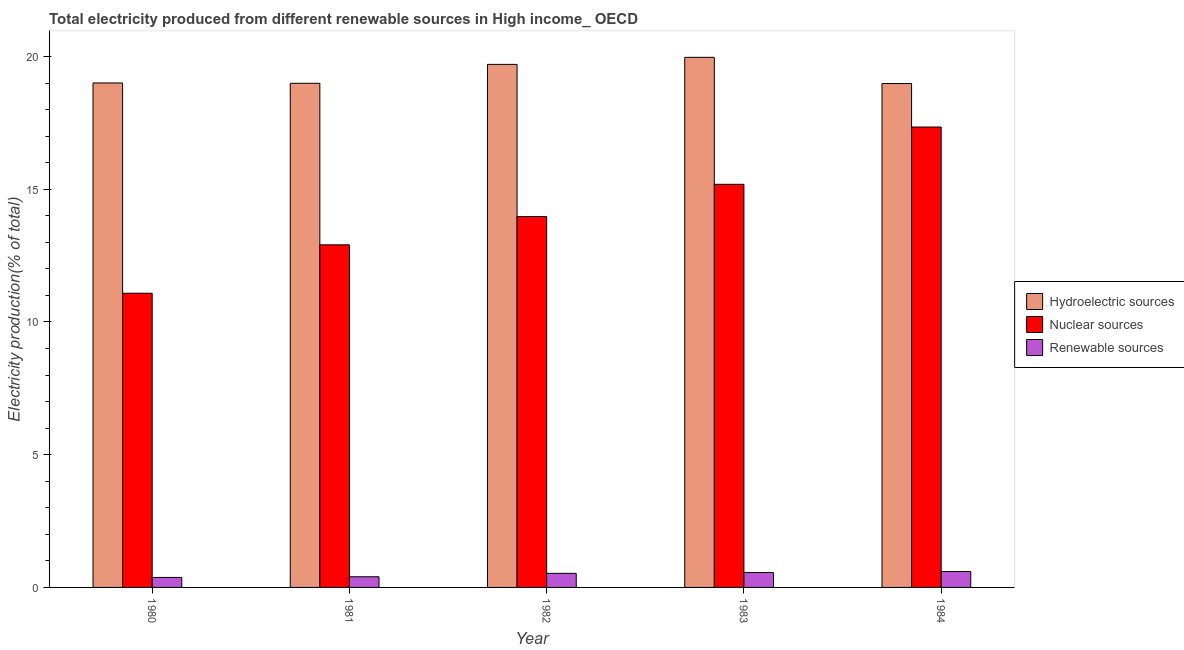How many different coloured bars are there?
Provide a short and direct response. 3. Are the number of bars on each tick of the X-axis equal?
Offer a terse response. Yes. What is the label of the 3rd group of bars from the left?
Ensure brevity in your answer.  1982. In how many cases, is the number of bars for a given year not equal to the number of legend labels?
Give a very brief answer. 0. What is the percentage of electricity produced by nuclear sources in 1983?
Offer a very short reply. 15.19. Across all years, what is the maximum percentage of electricity produced by hydroelectric sources?
Keep it short and to the point. 19.97. Across all years, what is the minimum percentage of electricity produced by hydroelectric sources?
Offer a very short reply. 18.98. In which year was the percentage of electricity produced by hydroelectric sources minimum?
Give a very brief answer. 1984. What is the total percentage of electricity produced by nuclear sources in the graph?
Offer a very short reply. 70.49. What is the difference between the percentage of electricity produced by hydroelectric sources in 1983 and that in 1984?
Offer a terse response. 0.99. What is the difference between the percentage of electricity produced by renewable sources in 1981 and the percentage of electricity produced by hydroelectric sources in 1984?
Provide a short and direct response. -0.2. What is the average percentage of electricity produced by nuclear sources per year?
Make the answer very short. 14.1. In how many years, is the percentage of electricity produced by renewable sources greater than 18 %?
Your response must be concise. 0. What is the ratio of the percentage of electricity produced by nuclear sources in 1980 to that in 1982?
Your answer should be compact. 0.79. Is the percentage of electricity produced by renewable sources in 1980 less than that in 1984?
Provide a succinct answer. Yes. What is the difference between the highest and the second highest percentage of electricity produced by renewable sources?
Ensure brevity in your answer.  0.04. What is the difference between the highest and the lowest percentage of electricity produced by nuclear sources?
Provide a succinct answer. 6.26. In how many years, is the percentage of electricity produced by renewable sources greater than the average percentage of electricity produced by renewable sources taken over all years?
Ensure brevity in your answer.  3. Is the sum of the percentage of electricity produced by nuclear sources in 1980 and 1982 greater than the maximum percentage of electricity produced by hydroelectric sources across all years?
Your answer should be compact. Yes. What does the 2nd bar from the left in 1980 represents?
Your answer should be very brief. Nuclear sources. What does the 1st bar from the right in 1980 represents?
Your answer should be compact. Renewable sources. How many bars are there?
Provide a short and direct response. 15. How many years are there in the graph?
Provide a short and direct response. 5. What is the difference between two consecutive major ticks on the Y-axis?
Ensure brevity in your answer.  5. Are the values on the major ticks of Y-axis written in scientific E-notation?
Provide a short and direct response. No. Where does the legend appear in the graph?
Offer a very short reply. Center right. How many legend labels are there?
Offer a terse response. 3. How are the legend labels stacked?
Your response must be concise. Vertical. What is the title of the graph?
Offer a terse response. Total electricity produced from different renewable sources in High income_ OECD. Does "Primary education" appear as one of the legend labels in the graph?
Your answer should be very brief. No. What is the label or title of the X-axis?
Your response must be concise. Year. What is the Electricity production(% of total) of Hydroelectric sources in 1980?
Your answer should be very brief. 19. What is the Electricity production(% of total) of Nuclear sources in 1980?
Provide a succinct answer. 11.08. What is the Electricity production(% of total) in Renewable sources in 1980?
Make the answer very short. 0.38. What is the Electricity production(% of total) of Hydroelectric sources in 1981?
Offer a terse response. 18.99. What is the Electricity production(% of total) of Nuclear sources in 1981?
Make the answer very short. 12.91. What is the Electricity production(% of total) of Renewable sources in 1981?
Provide a short and direct response. 0.4. What is the Electricity production(% of total) in Hydroelectric sources in 1982?
Your response must be concise. 19.7. What is the Electricity production(% of total) of Nuclear sources in 1982?
Keep it short and to the point. 13.97. What is the Electricity production(% of total) of Renewable sources in 1982?
Offer a very short reply. 0.53. What is the Electricity production(% of total) of Hydroelectric sources in 1983?
Your response must be concise. 19.97. What is the Electricity production(% of total) of Nuclear sources in 1983?
Offer a very short reply. 15.19. What is the Electricity production(% of total) of Renewable sources in 1983?
Your response must be concise. 0.56. What is the Electricity production(% of total) of Hydroelectric sources in 1984?
Provide a succinct answer. 18.98. What is the Electricity production(% of total) in Nuclear sources in 1984?
Provide a short and direct response. 17.34. What is the Electricity production(% of total) in Renewable sources in 1984?
Offer a terse response. 0.6. Across all years, what is the maximum Electricity production(% of total) of Hydroelectric sources?
Provide a succinct answer. 19.97. Across all years, what is the maximum Electricity production(% of total) in Nuclear sources?
Your response must be concise. 17.34. Across all years, what is the maximum Electricity production(% of total) in Renewable sources?
Your answer should be very brief. 0.6. Across all years, what is the minimum Electricity production(% of total) in Hydroelectric sources?
Keep it short and to the point. 18.98. Across all years, what is the minimum Electricity production(% of total) of Nuclear sources?
Your answer should be very brief. 11.08. Across all years, what is the minimum Electricity production(% of total) in Renewable sources?
Your answer should be compact. 0.38. What is the total Electricity production(% of total) in Hydroelectric sources in the graph?
Provide a short and direct response. 96.65. What is the total Electricity production(% of total) of Nuclear sources in the graph?
Your answer should be compact. 70.49. What is the total Electricity production(% of total) in Renewable sources in the graph?
Provide a short and direct response. 2.47. What is the difference between the Electricity production(% of total) in Hydroelectric sources in 1980 and that in 1981?
Your response must be concise. 0.01. What is the difference between the Electricity production(% of total) in Nuclear sources in 1980 and that in 1981?
Offer a terse response. -1.82. What is the difference between the Electricity production(% of total) in Renewable sources in 1980 and that in 1981?
Offer a very short reply. -0.03. What is the difference between the Electricity production(% of total) of Hydroelectric sources in 1980 and that in 1982?
Provide a succinct answer. -0.7. What is the difference between the Electricity production(% of total) in Nuclear sources in 1980 and that in 1982?
Ensure brevity in your answer.  -2.89. What is the difference between the Electricity production(% of total) of Renewable sources in 1980 and that in 1982?
Your answer should be very brief. -0.15. What is the difference between the Electricity production(% of total) in Hydroelectric sources in 1980 and that in 1983?
Your answer should be compact. -0.97. What is the difference between the Electricity production(% of total) of Nuclear sources in 1980 and that in 1983?
Provide a short and direct response. -4.1. What is the difference between the Electricity production(% of total) of Renewable sources in 1980 and that in 1983?
Offer a very short reply. -0.18. What is the difference between the Electricity production(% of total) of Hydroelectric sources in 1980 and that in 1984?
Offer a terse response. 0.02. What is the difference between the Electricity production(% of total) in Nuclear sources in 1980 and that in 1984?
Give a very brief answer. -6.26. What is the difference between the Electricity production(% of total) in Renewable sources in 1980 and that in 1984?
Your answer should be compact. -0.22. What is the difference between the Electricity production(% of total) of Hydroelectric sources in 1981 and that in 1982?
Make the answer very short. -0.71. What is the difference between the Electricity production(% of total) in Nuclear sources in 1981 and that in 1982?
Offer a very short reply. -1.07. What is the difference between the Electricity production(% of total) in Renewable sources in 1981 and that in 1982?
Provide a succinct answer. -0.13. What is the difference between the Electricity production(% of total) in Hydroelectric sources in 1981 and that in 1983?
Offer a very short reply. -0.98. What is the difference between the Electricity production(% of total) in Nuclear sources in 1981 and that in 1983?
Offer a very short reply. -2.28. What is the difference between the Electricity production(% of total) of Renewable sources in 1981 and that in 1983?
Your answer should be very brief. -0.16. What is the difference between the Electricity production(% of total) in Hydroelectric sources in 1981 and that in 1984?
Provide a succinct answer. 0.01. What is the difference between the Electricity production(% of total) in Nuclear sources in 1981 and that in 1984?
Provide a short and direct response. -4.44. What is the difference between the Electricity production(% of total) of Renewable sources in 1981 and that in 1984?
Offer a terse response. -0.2. What is the difference between the Electricity production(% of total) in Hydroelectric sources in 1982 and that in 1983?
Your answer should be very brief. -0.27. What is the difference between the Electricity production(% of total) in Nuclear sources in 1982 and that in 1983?
Your answer should be very brief. -1.21. What is the difference between the Electricity production(% of total) of Renewable sources in 1982 and that in 1983?
Ensure brevity in your answer.  -0.03. What is the difference between the Electricity production(% of total) of Hydroelectric sources in 1982 and that in 1984?
Your response must be concise. 0.72. What is the difference between the Electricity production(% of total) of Nuclear sources in 1982 and that in 1984?
Offer a terse response. -3.37. What is the difference between the Electricity production(% of total) in Renewable sources in 1982 and that in 1984?
Offer a very short reply. -0.07. What is the difference between the Electricity production(% of total) in Nuclear sources in 1983 and that in 1984?
Ensure brevity in your answer.  -2.16. What is the difference between the Electricity production(% of total) in Renewable sources in 1983 and that in 1984?
Offer a terse response. -0.04. What is the difference between the Electricity production(% of total) of Hydroelectric sources in 1980 and the Electricity production(% of total) of Nuclear sources in 1981?
Your answer should be compact. 6.1. What is the difference between the Electricity production(% of total) of Hydroelectric sources in 1980 and the Electricity production(% of total) of Renewable sources in 1981?
Make the answer very short. 18.6. What is the difference between the Electricity production(% of total) of Nuclear sources in 1980 and the Electricity production(% of total) of Renewable sources in 1981?
Keep it short and to the point. 10.68. What is the difference between the Electricity production(% of total) in Hydroelectric sources in 1980 and the Electricity production(% of total) in Nuclear sources in 1982?
Provide a succinct answer. 5.03. What is the difference between the Electricity production(% of total) in Hydroelectric sources in 1980 and the Electricity production(% of total) in Renewable sources in 1982?
Provide a short and direct response. 18.47. What is the difference between the Electricity production(% of total) in Nuclear sources in 1980 and the Electricity production(% of total) in Renewable sources in 1982?
Provide a short and direct response. 10.55. What is the difference between the Electricity production(% of total) in Hydroelectric sources in 1980 and the Electricity production(% of total) in Nuclear sources in 1983?
Give a very brief answer. 3.82. What is the difference between the Electricity production(% of total) in Hydroelectric sources in 1980 and the Electricity production(% of total) in Renewable sources in 1983?
Offer a terse response. 18.44. What is the difference between the Electricity production(% of total) of Nuclear sources in 1980 and the Electricity production(% of total) of Renewable sources in 1983?
Offer a terse response. 10.52. What is the difference between the Electricity production(% of total) in Hydroelectric sources in 1980 and the Electricity production(% of total) in Nuclear sources in 1984?
Your response must be concise. 1.66. What is the difference between the Electricity production(% of total) of Hydroelectric sources in 1980 and the Electricity production(% of total) of Renewable sources in 1984?
Offer a very short reply. 18.41. What is the difference between the Electricity production(% of total) in Nuclear sources in 1980 and the Electricity production(% of total) in Renewable sources in 1984?
Your answer should be very brief. 10.48. What is the difference between the Electricity production(% of total) in Hydroelectric sources in 1981 and the Electricity production(% of total) in Nuclear sources in 1982?
Provide a short and direct response. 5.02. What is the difference between the Electricity production(% of total) of Hydroelectric sources in 1981 and the Electricity production(% of total) of Renewable sources in 1982?
Keep it short and to the point. 18.46. What is the difference between the Electricity production(% of total) of Nuclear sources in 1981 and the Electricity production(% of total) of Renewable sources in 1982?
Give a very brief answer. 12.38. What is the difference between the Electricity production(% of total) of Hydroelectric sources in 1981 and the Electricity production(% of total) of Nuclear sources in 1983?
Make the answer very short. 3.81. What is the difference between the Electricity production(% of total) in Hydroelectric sources in 1981 and the Electricity production(% of total) in Renewable sources in 1983?
Give a very brief answer. 18.43. What is the difference between the Electricity production(% of total) in Nuclear sources in 1981 and the Electricity production(% of total) in Renewable sources in 1983?
Give a very brief answer. 12.34. What is the difference between the Electricity production(% of total) in Hydroelectric sources in 1981 and the Electricity production(% of total) in Nuclear sources in 1984?
Give a very brief answer. 1.65. What is the difference between the Electricity production(% of total) of Hydroelectric sources in 1981 and the Electricity production(% of total) of Renewable sources in 1984?
Offer a terse response. 18.39. What is the difference between the Electricity production(% of total) in Nuclear sources in 1981 and the Electricity production(% of total) in Renewable sources in 1984?
Your response must be concise. 12.31. What is the difference between the Electricity production(% of total) of Hydroelectric sources in 1982 and the Electricity production(% of total) of Nuclear sources in 1983?
Your answer should be compact. 4.52. What is the difference between the Electricity production(% of total) in Hydroelectric sources in 1982 and the Electricity production(% of total) in Renewable sources in 1983?
Your answer should be very brief. 19.14. What is the difference between the Electricity production(% of total) in Nuclear sources in 1982 and the Electricity production(% of total) in Renewable sources in 1983?
Keep it short and to the point. 13.41. What is the difference between the Electricity production(% of total) of Hydroelectric sources in 1982 and the Electricity production(% of total) of Nuclear sources in 1984?
Your answer should be compact. 2.36. What is the difference between the Electricity production(% of total) in Hydroelectric sources in 1982 and the Electricity production(% of total) in Renewable sources in 1984?
Your answer should be compact. 19.11. What is the difference between the Electricity production(% of total) of Nuclear sources in 1982 and the Electricity production(% of total) of Renewable sources in 1984?
Offer a very short reply. 13.37. What is the difference between the Electricity production(% of total) in Hydroelectric sources in 1983 and the Electricity production(% of total) in Nuclear sources in 1984?
Offer a very short reply. 2.63. What is the difference between the Electricity production(% of total) in Hydroelectric sources in 1983 and the Electricity production(% of total) in Renewable sources in 1984?
Provide a succinct answer. 19.37. What is the difference between the Electricity production(% of total) in Nuclear sources in 1983 and the Electricity production(% of total) in Renewable sources in 1984?
Ensure brevity in your answer.  14.59. What is the average Electricity production(% of total) in Hydroelectric sources per year?
Provide a succinct answer. 19.33. What is the average Electricity production(% of total) in Nuclear sources per year?
Give a very brief answer. 14.1. What is the average Electricity production(% of total) of Renewable sources per year?
Ensure brevity in your answer.  0.49. In the year 1980, what is the difference between the Electricity production(% of total) of Hydroelectric sources and Electricity production(% of total) of Nuclear sources?
Ensure brevity in your answer.  7.92. In the year 1980, what is the difference between the Electricity production(% of total) in Hydroelectric sources and Electricity production(% of total) in Renewable sources?
Give a very brief answer. 18.63. In the year 1980, what is the difference between the Electricity production(% of total) in Nuclear sources and Electricity production(% of total) in Renewable sources?
Give a very brief answer. 10.71. In the year 1981, what is the difference between the Electricity production(% of total) in Hydroelectric sources and Electricity production(% of total) in Nuclear sources?
Your answer should be compact. 6.09. In the year 1981, what is the difference between the Electricity production(% of total) of Hydroelectric sources and Electricity production(% of total) of Renewable sources?
Give a very brief answer. 18.59. In the year 1981, what is the difference between the Electricity production(% of total) of Nuclear sources and Electricity production(% of total) of Renewable sources?
Your response must be concise. 12.5. In the year 1982, what is the difference between the Electricity production(% of total) of Hydroelectric sources and Electricity production(% of total) of Nuclear sources?
Your response must be concise. 5.73. In the year 1982, what is the difference between the Electricity production(% of total) in Hydroelectric sources and Electricity production(% of total) in Renewable sources?
Keep it short and to the point. 19.17. In the year 1982, what is the difference between the Electricity production(% of total) in Nuclear sources and Electricity production(% of total) in Renewable sources?
Make the answer very short. 13.44. In the year 1983, what is the difference between the Electricity production(% of total) in Hydroelectric sources and Electricity production(% of total) in Nuclear sources?
Keep it short and to the point. 4.78. In the year 1983, what is the difference between the Electricity production(% of total) of Hydroelectric sources and Electricity production(% of total) of Renewable sources?
Offer a very short reply. 19.41. In the year 1983, what is the difference between the Electricity production(% of total) in Nuclear sources and Electricity production(% of total) in Renewable sources?
Your answer should be compact. 14.62. In the year 1984, what is the difference between the Electricity production(% of total) in Hydroelectric sources and Electricity production(% of total) in Nuclear sources?
Offer a very short reply. 1.64. In the year 1984, what is the difference between the Electricity production(% of total) in Hydroelectric sources and Electricity production(% of total) in Renewable sources?
Offer a terse response. 18.38. In the year 1984, what is the difference between the Electricity production(% of total) in Nuclear sources and Electricity production(% of total) in Renewable sources?
Offer a terse response. 16.74. What is the ratio of the Electricity production(% of total) in Hydroelectric sources in 1980 to that in 1981?
Make the answer very short. 1. What is the ratio of the Electricity production(% of total) in Nuclear sources in 1980 to that in 1981?
Give a very brief answer. 0.86. What is the ratio of the Electricity production(% of total) in Renewable sources in 1980 to that in 1981?
Your answer should be very brief. 0.94. What is the ratio of the Electricity production(% of total) of Hydroelectric sources in 1980 to that in 1982?
Give a very brief answer. 0.96. What is the ratio of the Electricity production(% of total) in Nuclear sources in 1980 to that in 1982?
Offer a terse response. 0.79. What is the ratio of the Electricity production(% of total) in Renewable sources in 1980 to that in 1982?
Provide a succinct answer. 0.71. What is the ratio of the Electricity production(% of total) in Hydroelectric sources in 1980 to that in 1983?
Keep it short and to the point. 0.95. What is the ratio of the Electricity production(% of total) in Nuclear sources in 1980 to that in 1983?
Provide a succinct answer. 0.73. What is the ratio of the Electricity production(% of total) in Renewable sources in 1980 to that in 1983?
Your answer should be compact. 0.67. What is the ratio of the Electricity production(% of total) of Nuclear sources in 1980 to that in 1984?
Offer a terse response. 0.64. What is the ratio of the Electricity production(% of total) of Renewable sources in 1980 to that in 1984?
Make the answer very short. 0.63. What is the ratio of the Electricity production(% of total) of Hydroelectric sources in 1981 to that in 1982?
Make the answer very short. 0.96. What is the ratio of the Electricity production(% of total) of Nuclear sources in 1981 to that in 1982?
Your response must be concise. 0.92. What is the ratio of the Electricity production(% of total) of Renewable sources in 1981 to that in 1982?
Your answer should be compact. 0.76. What is the ratio of the Electricity production(% of total) in Hydroelectric sources in 1981 to that in 1983?
Keep it short and to the point. 0.95. What is the ratio of the Electricity production(% of total) of Nuclear sources in 1981 to that in 1983?
Your response must be concise. 0.85. What is the ratio of the Electricity production(% of total) of Renewable sources in 1981 to that in 1983?
Your response must be concise. 0.72. What is the ratio of the Electricity production(% of total) in Hydroelectric sources in 1981 to that in 1984?
Keep it short and to the point. 1. What is the ratio of the Electricity production(% of total) in Nuclear sources in 1981 to that in 1984?
Make the answer very short. 0.74. What is the ratio of the Electricity production(% of total) in Renewable sources in 1981 to that in 1984?
Ensure brevity in your answer.  0.67. What is the ratio of the Electricity production(% of total) in Hydroelectric sources in 1982 to that in 1983?
Keep it short and to the point. 0.99. What is the ratio of the Electricity production(% of total) of Nuclear sources in 1982 to that in 1983?
Your answer should be very brief. 0.92. What is the ratio of the Electricity production(% of total) in Renewable sources in 1982 to that in 1983?
Give a very brief answer. 0.95. What is the ratio of the Electricity production(% of total) of Hydroelectric sources in 1982 to that in 1984?
Offer a terse response. 1.04. What is the ratio of the Electricity production(% of total) in Nuclear sources in 1982 to that in 1984?
Keep it short and to the point. 0.81. What is the ratio of the Electricity production(% of total) of Renewable sources in 1982 to that in 1984?
Provide a succinct answer. 0.89. What is the ratio of the Electricity production(% of total) of Hydroelectric sources in 1983 to that in 1984?
Keep it short and to the point. 1.05. What is the ratio of the Electricity production(% of total) of Nuclear sources in 1983 to that in 1984?
Offer a terse response. 0.88. What is the ratio of the Electricity production(% of total) of Renewable sources in 1983 to that in 1984?
Make the answer very short. 0.94. What is the difference between the highest and the second highest Electricity production(% of total) of Hydroelectric sources?
Your answer should be very brief. 0.27. What is the difference between the highest and the second highest Electricity production(% of total) of Nuclear sources?
Make the answer very short. 2.16. What is the difference between the highest and the second highest Electricity production(% of total) in Renewable sources?
Provide a succinct answer. 0.04. What is the difference between the highest and the lowest Electricity production(% of total) of Nuclear sources?
Offer a very short reply. 6.26. What is the difference between the highest and the lowest Electricity production(% of total) of Renewable sources?
Provide a short and direct response. 0.22. 